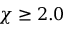Convert formula to latex. <formula><loc_0><loc_0><loc_500><loc_500>\chi \geq 2 . 0</formula> 